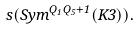Convert formula to latex. <formula><loc_0><loc_0><loc_500><loc_500>\ s ( S y m ^ { Q _ { 1 } Q _ { 5 } + 1 } ( K 3 ) ) .</formula> 